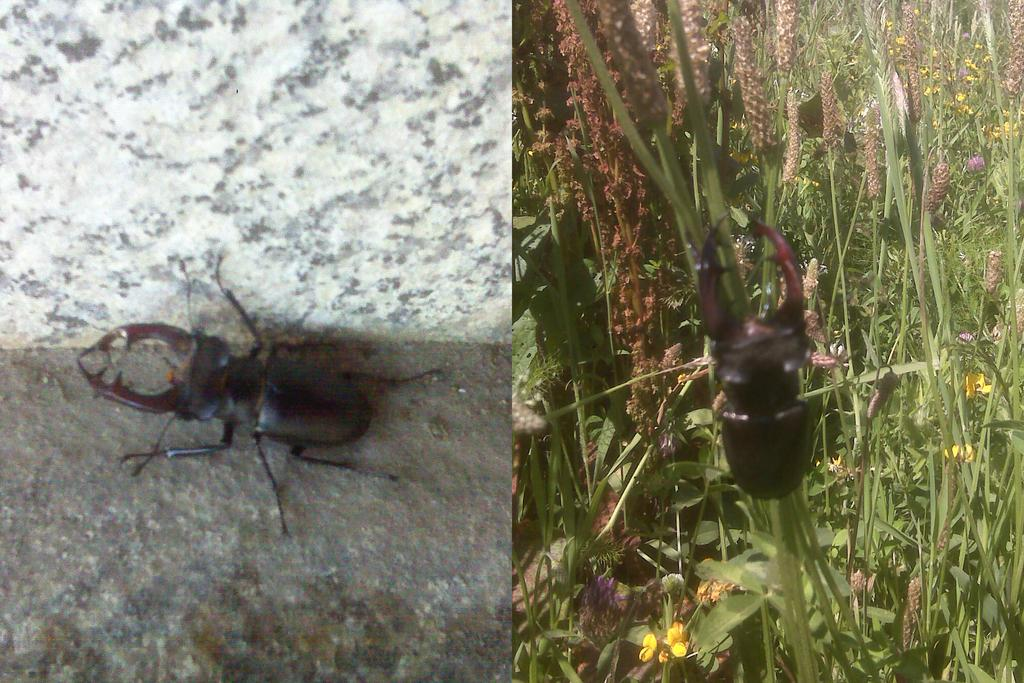How many insects are present in the image? There are two insects in the image. Where is one of the insects located? One insect is on the floor. Where is the other insect located? The other insect is on the grass. What type of bridge can be seen in the image? There is no bridge present in the image; it features two insects, one on the floor and the other on the grass. 